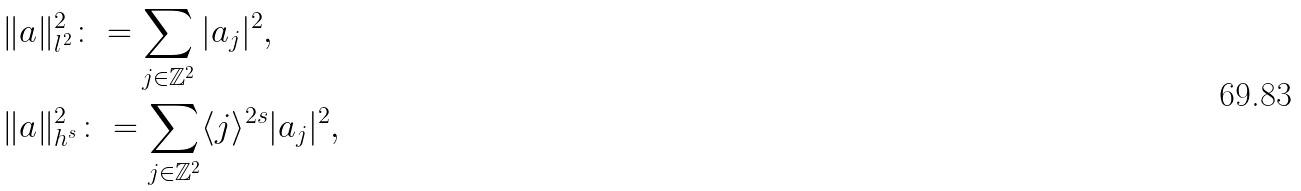<formula> <loc_0><loc_0><loc_500><loc_500>& \| a \| _ { l ^ { 2 } } ^ { 2 } \colon = \sum _ { j \in \mathbb { Z } ^ { 2 } } | a _ { j } | ^ { 2 } , \\ & \| a \| _ { h ^ { s } } ^ { 2 } \colon = \sum _ { j \in \mathbb { Z } ^ { 2 } } \langle j \rangle ^ { 2 s } | a _ { j } | ^ { 2 } ,</formula> 